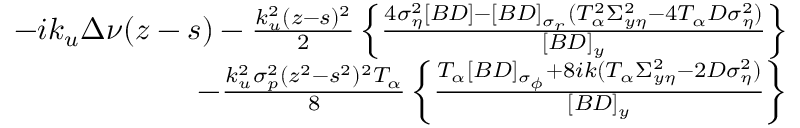<formula> <loc_0><loc_0><loc_500><loc_500>\begin{array} { r l r } & { - i k _ { u } \Delta \nu ( z - s ) - \frac { k _ { u } ^ { 2 } ( z - s ) ^ { 2 } } { 2 } \left \{ \frac { 4 \sigma _ { \eta } ^ { 2 } [ B D ] - [ B D ] _ { \sigma _ { r } } ( T _ { \alpha } ^ { 2 } \Sigma _ { y \eta } ^ { 2 } - 4 T _ { \alpha } D \sigma _ { \eta } ^ { 2 } ) } { [ B D ] _ { y } } \right \} } \\ & { \quad - \frac { k _ { u } ^ { 2 } \sigma _ { p } ^ { 2 } ( z ^ { 2 } - s ^ { 2 } ) ^ { 2 } T _ { \alpha } } { 8 } \left \{ \frac { T _ { \alpha } [ B D ] _ { \sigma _ { \phi } } + 8 i k ( T _ { \alpha } \Sigma _ { y \eta } ^ { 2 } - 2 D \sigma _ { \eta } ^ { 2 } ) } { [ B D ] _ { y } } \right \} } \end{array}</formula> 